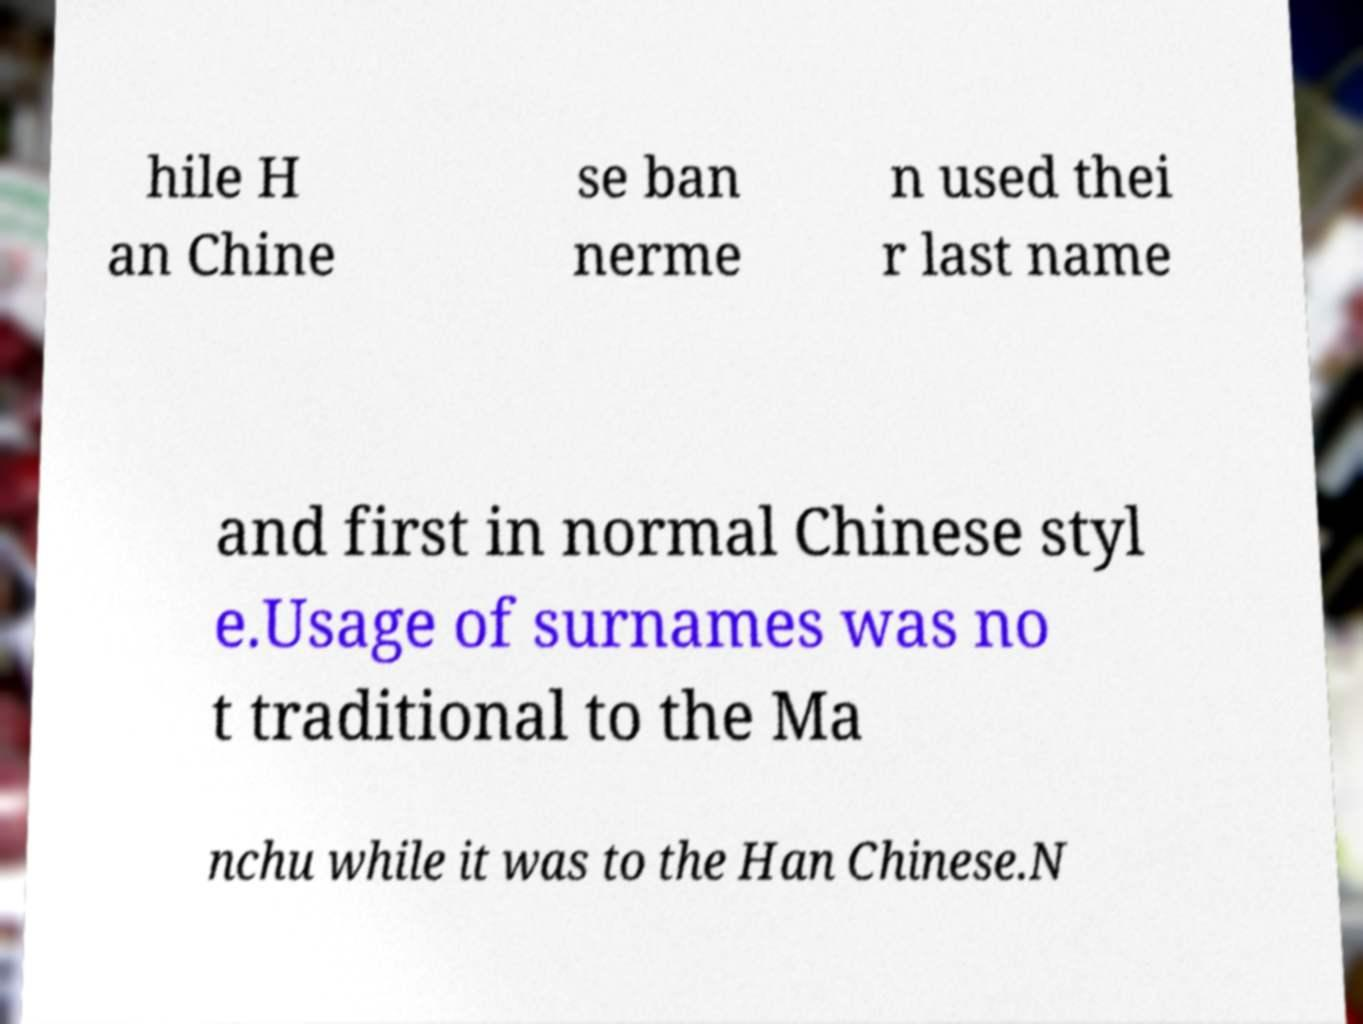Please identify and transcribe the text found in this image. hile H an Chine se ban nerme n used thei r last name and first in normal Chinese styl e.Usage of surnames was no t traditional to the Ma nchu while it was to the Han Chinese.N 